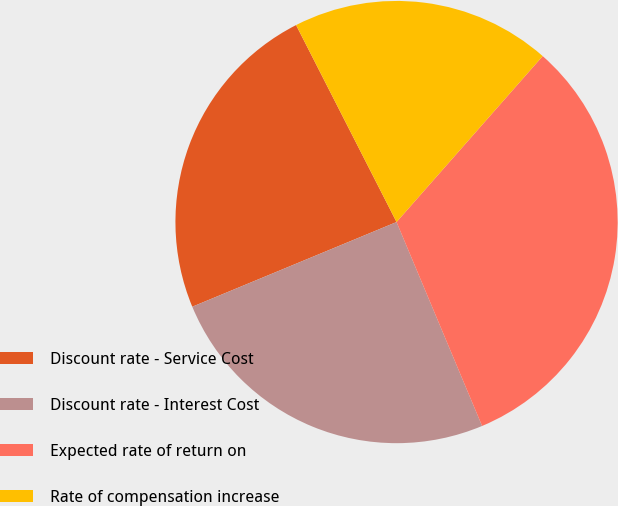Convert chart. <chart><loc_0><loc_0><loc_500><loc_500><pie_chart><fcel>Discount rate - Service Cost<fcel>Discount rate - Interest Cost<fcel>Expected rate of return on<fcel>Rate of compensation increase<nl><fcel>23.75%<fcel>25.07%<fcel>32.19%<fcel>19.0%<nl></chart> 